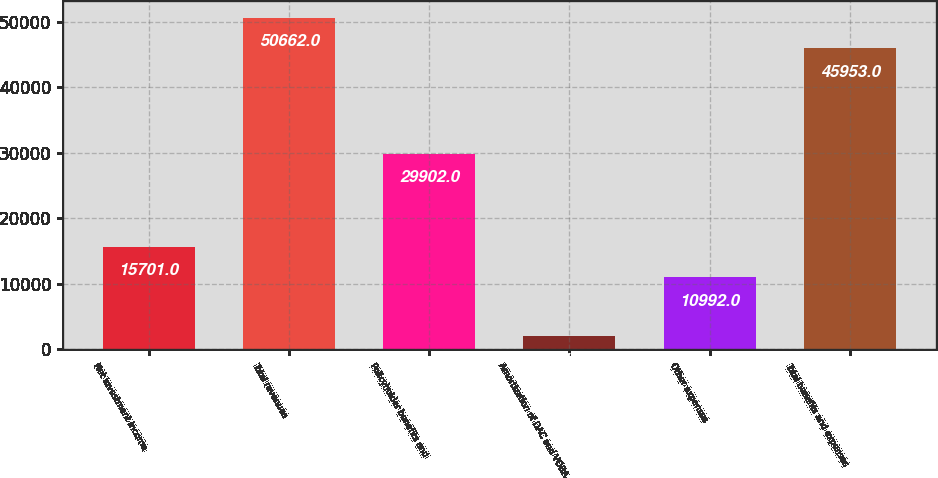Convert chart to OTSL. <chart><loc_0><loc_0><loc_500><loc_500><bar_chart><fcel>Net investment income<fcel>Total revenues<fcel>Policyholder benefits and<fcel>Amortization of DAC and VOBA<fcel>Other expenses<fcel>Total benefits and expenses<nl><fcel>15701<fcel>50662<fcel>29902<fcel>2018<fcel>10992<fcel>45953<nl></chart> 